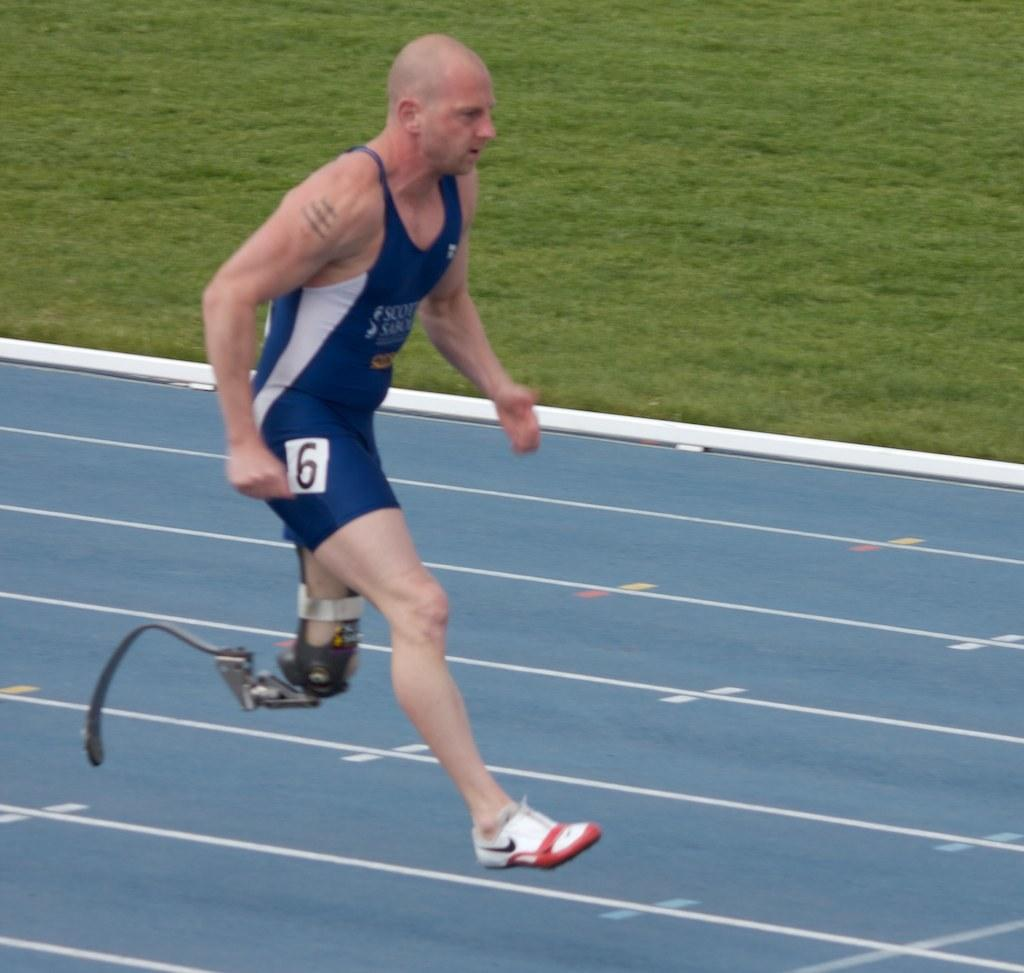What is happening in the image? There is a person in the image, and they are running on the ground. What type of surface is the person running on? The person is running on the ground. What can be seen in the background of the image? There is grass visible in the background of the image. What type of oven can be seen in the image? There is no oven present in the image; it features a person running on the ground with grass visible in the background. 